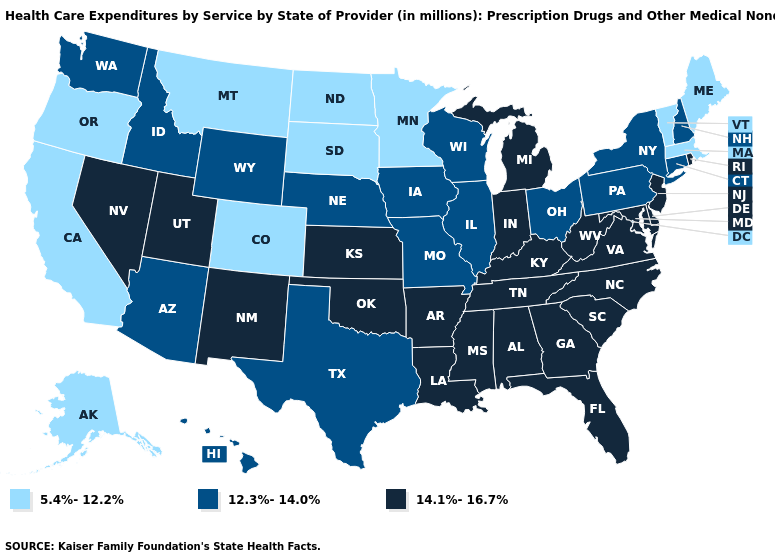What is the value of Georgia?
Give a very brief answer. 14.1%-16.7%. Name the states that have a value in the range 12.3%-14.0%?
Quick response, please. Arizona, Connecticut, Hawaii, Idaho, Illinois, Iowa, Missouri, Nebraska, New Hampshire, New York, Ohio, Pennsylvania, Texas, Washington, Wisconsin, Wyoming. Name the states that have a value in the range 12.3%-14.0%?
Quick response, please. Arizona, Connecticut, Hawaii, Idaho, Illinois, Iowa, Missouri, Nebraska, New Hampshire, New York, Ohio, Pennsylvania, Texas, Washington, Wisconsin, Wyoming. Does South Carolina have the highest value in the USA?
Give a very brief answer. Yes. Does the first symbol in the legend represent the smallest category?
Concise answer only. Yes. What is the highest value in the West ?
Quick response, please. 14.1%-16.7%. What is the lowest value in the West?
Write a very short answer. 5.4%-12.2%. Name the states that have a value in the range 14.1%-16.7%?
Concise answer only. Alabama, Arkansas, Delaware, Florida, Georgia, Indiana, Kansas, Kentucky, Louisiana, Maryland, Michigan, Mississippi, Nevada, New Jersey, New Mexico, North Carolina, Oklahoma, Rhode Island, South Carolina, Tennessee, Utah, Virginia, West Virginia. What is the value of Wyoming?
Give a very brief answer. 12.3%-14.0%. How many symbols are there in the legend?
Quick response, please. 3. What is the lowest value in states that border Montana?
Short answer required. 5.4%-12.2%. Does Connecticut have a lower value than Oregon?
Answer briefly. No. Name the states that have a value in the range 5.4%-12.2%?
Write a very short answer. Alaska, California, Colorado, Maine, Massachusetts, Minnesota, Montana, North Dakota, Oregon, South Dakota, Vermont. Does Alabama have the highest value in the USA?
Short answer required. Yes. Name the states that have a value in the range 12.3%-14.0%?
Write a very short answer. Arizona, Connecticut, Hawaii, Idaho, Illinois, Iowa, Missouri, Nebraska, New Hampshire, New York, Ohio, Pennsylvania, Texas, Washington, Wisconsin, Wyoming. 